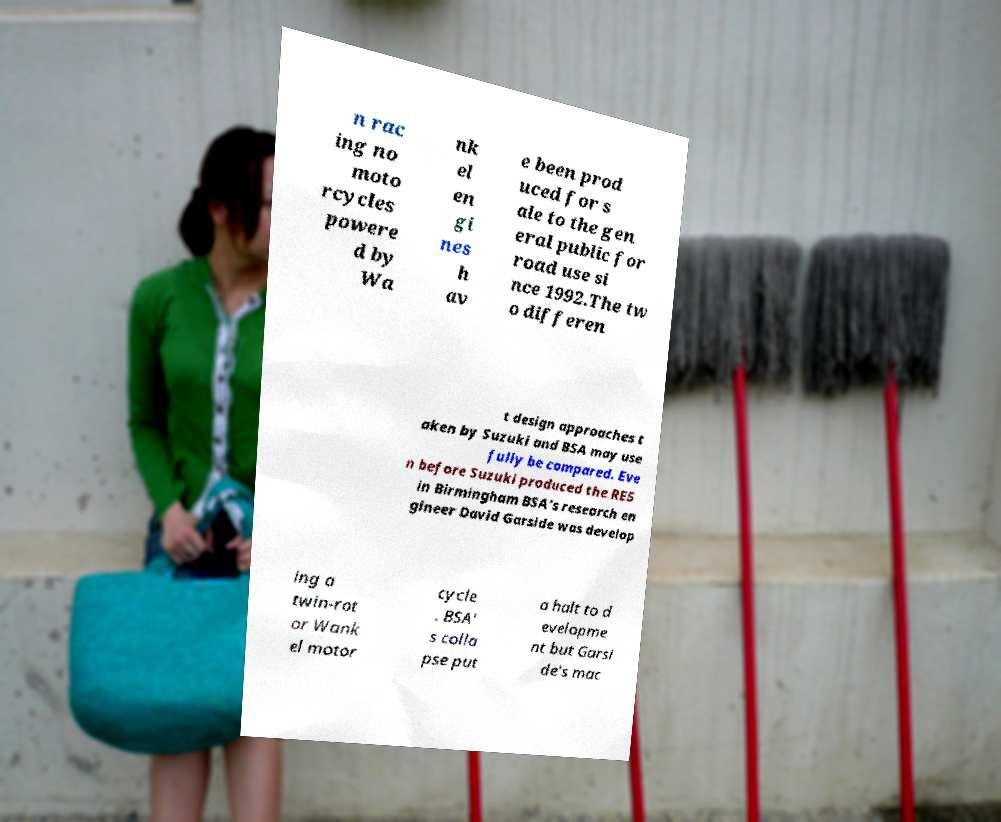What messages or text are displayed in this image? I need them in a readable, typed format. n rac ing no moto rcycles powere d by Wa nk el en gi nes h av e been prod uced for s ale to the gen eral public for road use si nce 1992.The tw o differen t design approaches t aken by Suzuki and BSA may use fully be compared. Eve n before Suzuki produced the RE5 in Birmingham BSA's research en gineer David Garside was develop ing a twin-rot or Wank el motor cycle . BSA' s colla pse put a halt to d evelopme nt but Garsi de's mac 